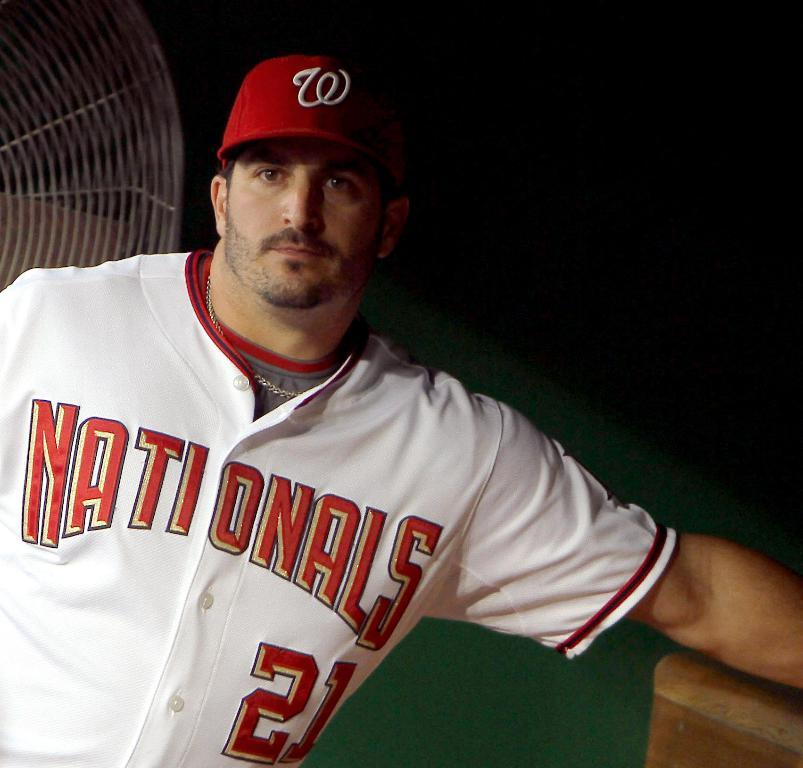<image>
Create a compact narrative representing the image presented. Player 21 of the Nationals looking at the camera. 